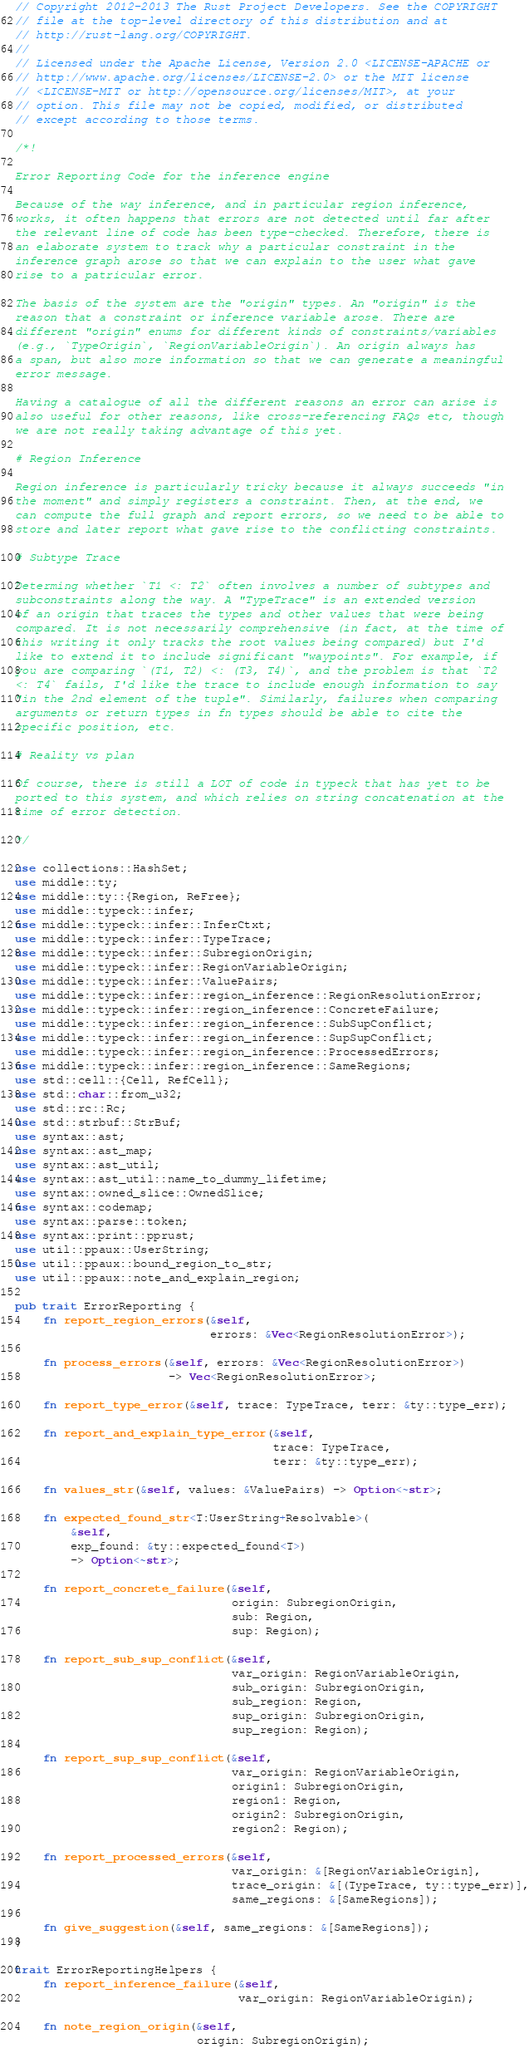Convert code to text. <code><loc_0><loc_0><loc_500><loc_500><_Rust_>// Copyright 2012-2013 The Rust Project Developers. See the COPYRIGHT
// file at the top-level directory of this distribution and at
// http://rust-lang.org/COPYRIGHT.
//
// Licensed under the Apache License, Version 2.0 <LICENSE-APACHE or
// http://www.apache.org/licenses/LICENSE-2.0> or the MIT license
// <LICENSE-MIT or http://opensource.org/licenses/MIT>, at your
// option. This file may not be copied, modified, or distributed
// except according to those terms.

/*!

Error Reporting Code for the inference engine

Because of the way inference, and in particular region inference,
works, it often happens that errors are not detected until far after
the relevant line of code has been type-checked. Therefore, there is
an elaborate system to track why a particular constraint in the
inference graph arose so that we can explain to the user what gave
rise to a patricular error.

The basis of the system are the "origin" types. An "origin" is the
reason that a constraint or inference variable arose. There are
different "origin" enums for different kinds of constraints/variables
(e.g., `TypeOrigin`, `RegionVariableOrigin`). An origin always has
a span, but also more information so that we can generate a meaningful
error message.

Having a catalogue of all the different reasons an error can arise is
also useful for other reasons, like cross-referencing FAQs etc, though
we are not really taking advantage of this yet.

# Region Inference

Region inference is particularly tricky because it always succeeds "in
the moment" and simply registers a constraint. Then, at the end, we
can compute the full graph and report errors, so we need to be able to
store and later report what gave rise to the conflicting constraints.

# Subtype Trace

Determing whether `T1 <: T2` often involves a number of subtypes and
subconstraints along the way. A "TypeTrace" is an extended version
of an origin that traces the types and other values that were being
compared. It is not necessarily comprehensive (in fact, at the time of
this writing it only tracks the root values being compared) but I'd
like to extend it to include significant "waypoints". For example, if
you are comparing `(T1, T2) <: (T3, T4)`, and the problem is that `T2
<: T4` fails, I'd like the trace to include enough information to say
"in the 2nd element of the tuple". Similarly, failures when comparing
arguments or return types in fn types should be able to cite the
specific position, etc.

# Reality vs plan

Of course, there is still a LOT of code in typeck that has yet to be
ported to this system, and which relies on string concatenation at the
time of error detection.

*/

use collections::HashSet;
use middle::ty;
use middle::ty::{Region, ReFree};
use middle::typeck::infer;
use middle::typeck::infer::InferCtxt;
use middle::typeck::infer::TypeTrace;
use middle::typeck::infer::SubregionOrigin;
use middle::typeck::infer::RegionVariableOrigin;
use middle::typeck::infer::ValuePairs;
use middle::typeck::infer::region_inference::RegionResolutionError;
use middle::typeck::infer::region_inference::ConcreteFailure;
use middle::typeck::infer::region_inference::SubSupConflict;
use middle::typeck::infer::region_inference::SupSupConflict;
use middle::typeck::infer::region_inference::ProcessedErrors;
use middle::typeck::infer::region_inference::SameRegions;
use std::cell::{Cell, RefCell};
use std::char::from_u32;
use std::rc::Rc;
use std::strbuf::StrBuf;
use syntax::ast;
use syntax::ast_map;
use syntax::ast_util;
use syntax::ast_util::name_to_dummy_lifetime;
use syntax::owned_slice::OwnedSlice;
use syntax::codemap;
use syntax::parse::token;
use syntax::print::pprust;
use util::ppaux::UserString;
use util::ppaux::bound_region_to_str;
use util::ppaux::note_and_explain_region;

pub trait ErrorReporting {
    fn report_region_errors(&self,
                            errors: &Vec<RegionResolutionError>);

    fn process_errors(&self, errors: &Vec<RegionResolutionError>)
                      -> Vec<RegionResolutionError>;

    fn report_type_error(&self, trace: TypeTrace, terr: &ty::type_err);

    fn report_and_explain_type_error(&self,
                                     trace: TypeTrace,
                                     terr: &ty::type_err);

    fn values_str(&self, values: &ValuePairs) -> Option<~str>;

    fn expected_found_str<T:UserString+Resolvable>(
        &self,
        exp_found: &ty::expected_found<T>)
        -> Option<~str>;

    fn report_concrete_failure(&self,
                               origin: SubregionOrigin,
                               sub: Region,
                               sup: Region);

    fn report_sub_sup_conflict(&self,
                               var_origin: RegionVariableOrigin,
                               sub_origin: SubregionOrigin,
                               sub_region: Region,
                               sup_origin: SubregionOrigin,
                               sup_region: Region);

    fn report_sup_sup_conflict(&self,
                               var_origin: RegionVariableOrigin,
                               origin1: SubregionOrigin,
                               region1: Region,
                               origin2: SubregionOrigin,
                               region2: Region);

    fn report_processed_errors(&self,
                               var_origin: &[RegionVariableOrigin],
                               trace_origin: &[(TypeTrace, ty::type_err)],
                               same_regions: &[SameRegions]);

    fn give_suggestion(&self, same_regions: &[SameRegions]);
}

trait ErrorReportingHelpers {
    fn report_inference_failure(&self,
                                var_origin: RegionVariableOrigin);

    fn note_region_origin(&self,
                          origin: SubregionOrigin);
</code> 